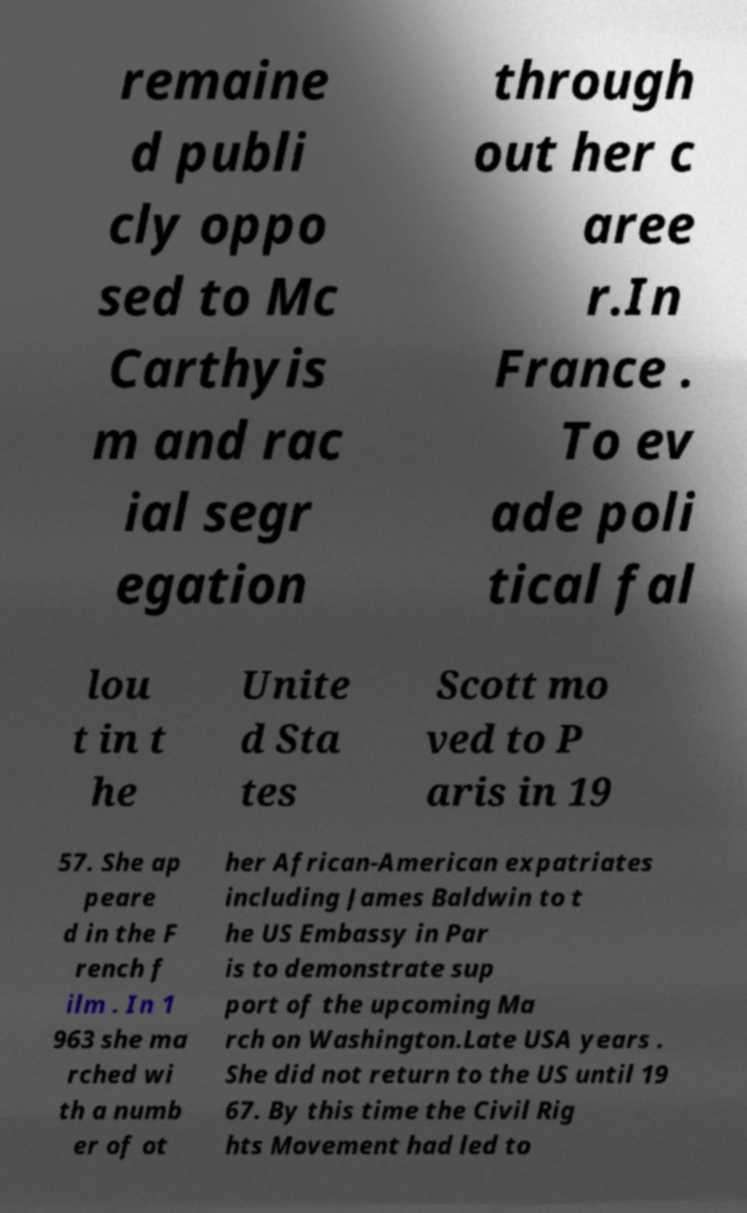Can you read and provide the text displayed in the image?This photo seems to have some interesting text. Can you extract and type it out for me? remaine d publi cly oppo sed to Mc Carthyis m and rac ial segr egation through out her c aree r.In France . To ev ade poli tical fal lou t in t he Unite d Sta tes Scott mo ved to P aris in 19 57. She ap peare d in the F rench f ilm . In 1 963 she ma rched wi th a numb er of ot her African-American expatriates including James Baldwin to t he US Embassy in Par is to demonstrate sup port of the upcoming Ma rch on Washington.Late USA years . She did not return to the US until 19 67. By this time the Civil Rig hts Movement had led to 